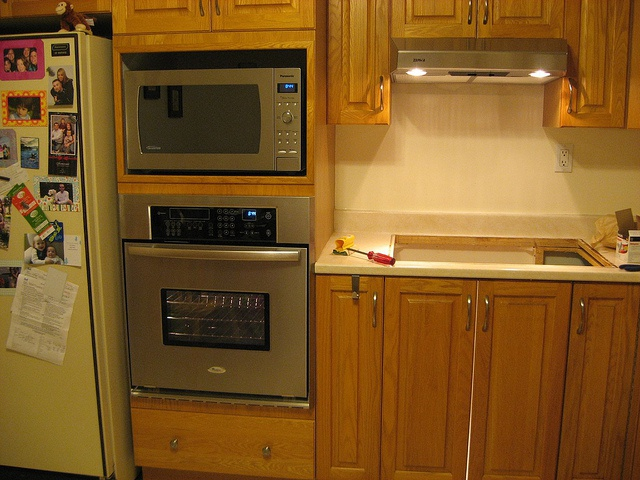Describe the objects in this image and their specific colors. I can see refrigerator in maroon, olive, tan, and black tones, oven in maroon, olive, and black tones, microwave in maroon, black, and olive tones, and dog in maroon, gray, tan, black, and olive tones in this image. 